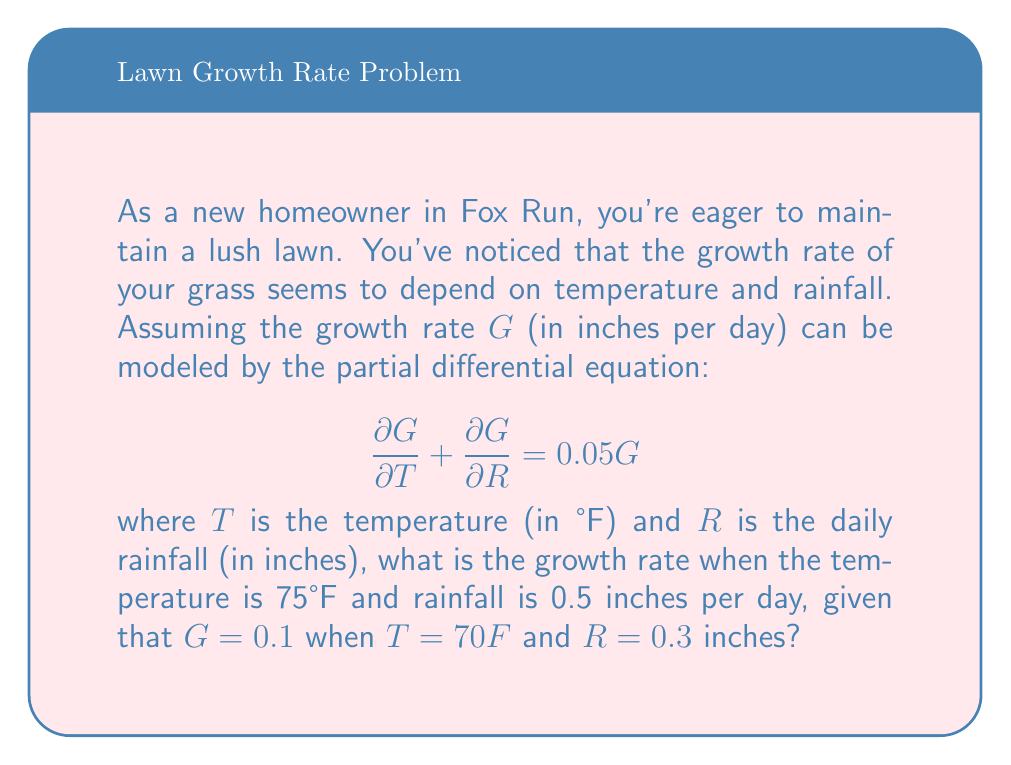Solve this math problem. Let's approach this step-by-step:

1) We're given a partial differential equation (PDE):

   $$\frac{\partial G}{\partial T} + \frac{\partial G}{\partial R} = 0.05G$$

2) This is a linear first-order PDE. The general solution to this type of equation is:

   $$G(T,R) = f(T-R)e^{0.05(T+R)}$$

   where $f$ is an arbitrary function.

3) We're given an initial condition: $G = 0.1$ when $T = 70°F$ and $R = 0.3$ inches.
   Let's use this to find $f$:

   $$0.1 = f(70-0.3)e^{0.05(70+0.3)}$$
   $$f(69.7) = 0.1e^{-3.515} = 0.1 \cdot 0.0297 = 0.00297$$

4) So our specific solution is:

   $$G(T,R) = 0.00297e^{0.05(T+R-69.7)}$$

5) Now, we need to find $G$ when $T = 75°F$ and $R = 0.5$ inches:

   $$G(75,0.5) = 0.00297e^{0.05(75+0.5-69.7)}$$
   $$= 0.00297e^{0.05(5.8)}$$
   $$= 0.00297e^{0.29}$$
   $$= 0.00297 \cdot 1.3364$$
   $$= 0.00397$$

Thus, the growth rate under these conditions is approximately 0.00397 inches per day.
Answer: $G(75,0.5) \approx 0.00397$ inches per day 